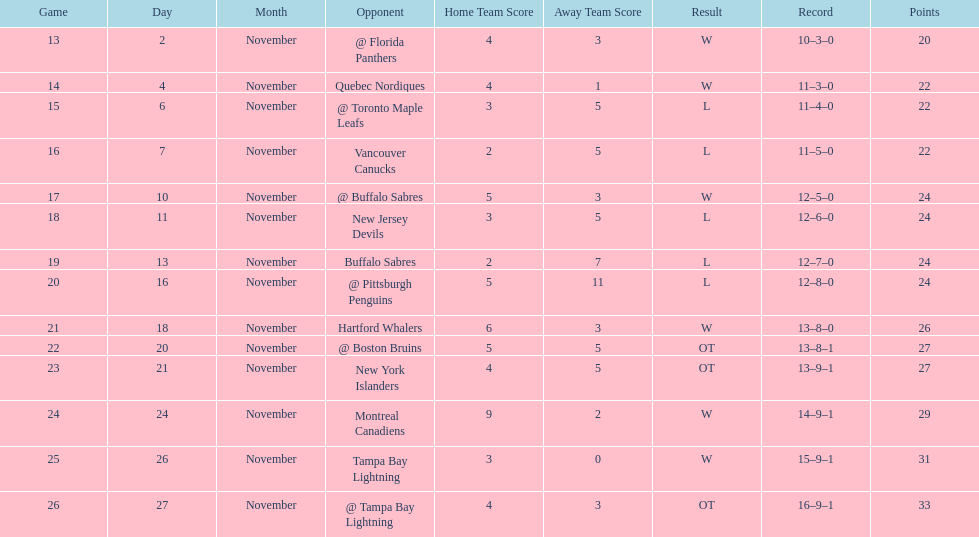What was the total penalty minutes that dave brown had on the 1993-1994 flyers? 137. 